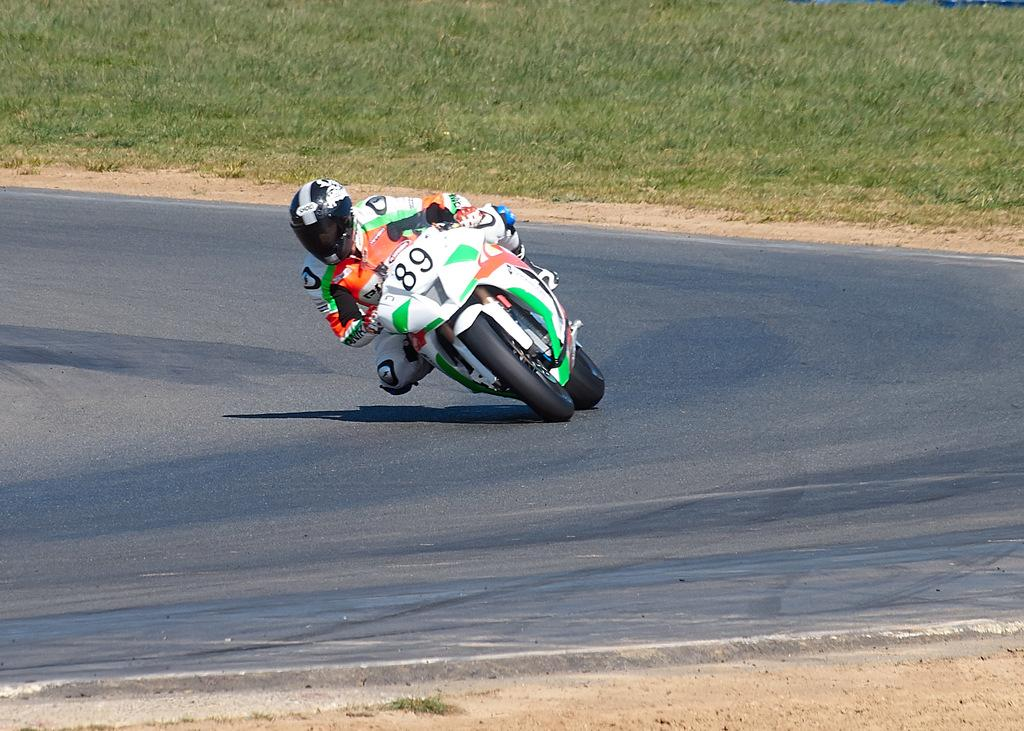What is the person in the image doing? The person in the image is riding a bike. What safety precaution is the person taking while riding the bike? The person is wearing a helmet. What type of clothing is the person wearing? The person is wearing a suit. What can be seen in the background of the image? There is grass visible in the background of the image. What type of carriage is the person pulling in the image? There is no carriage present in the image; the person is riding a bike. What date is marked on the calendar in the image? There is no calendar present in the image. 